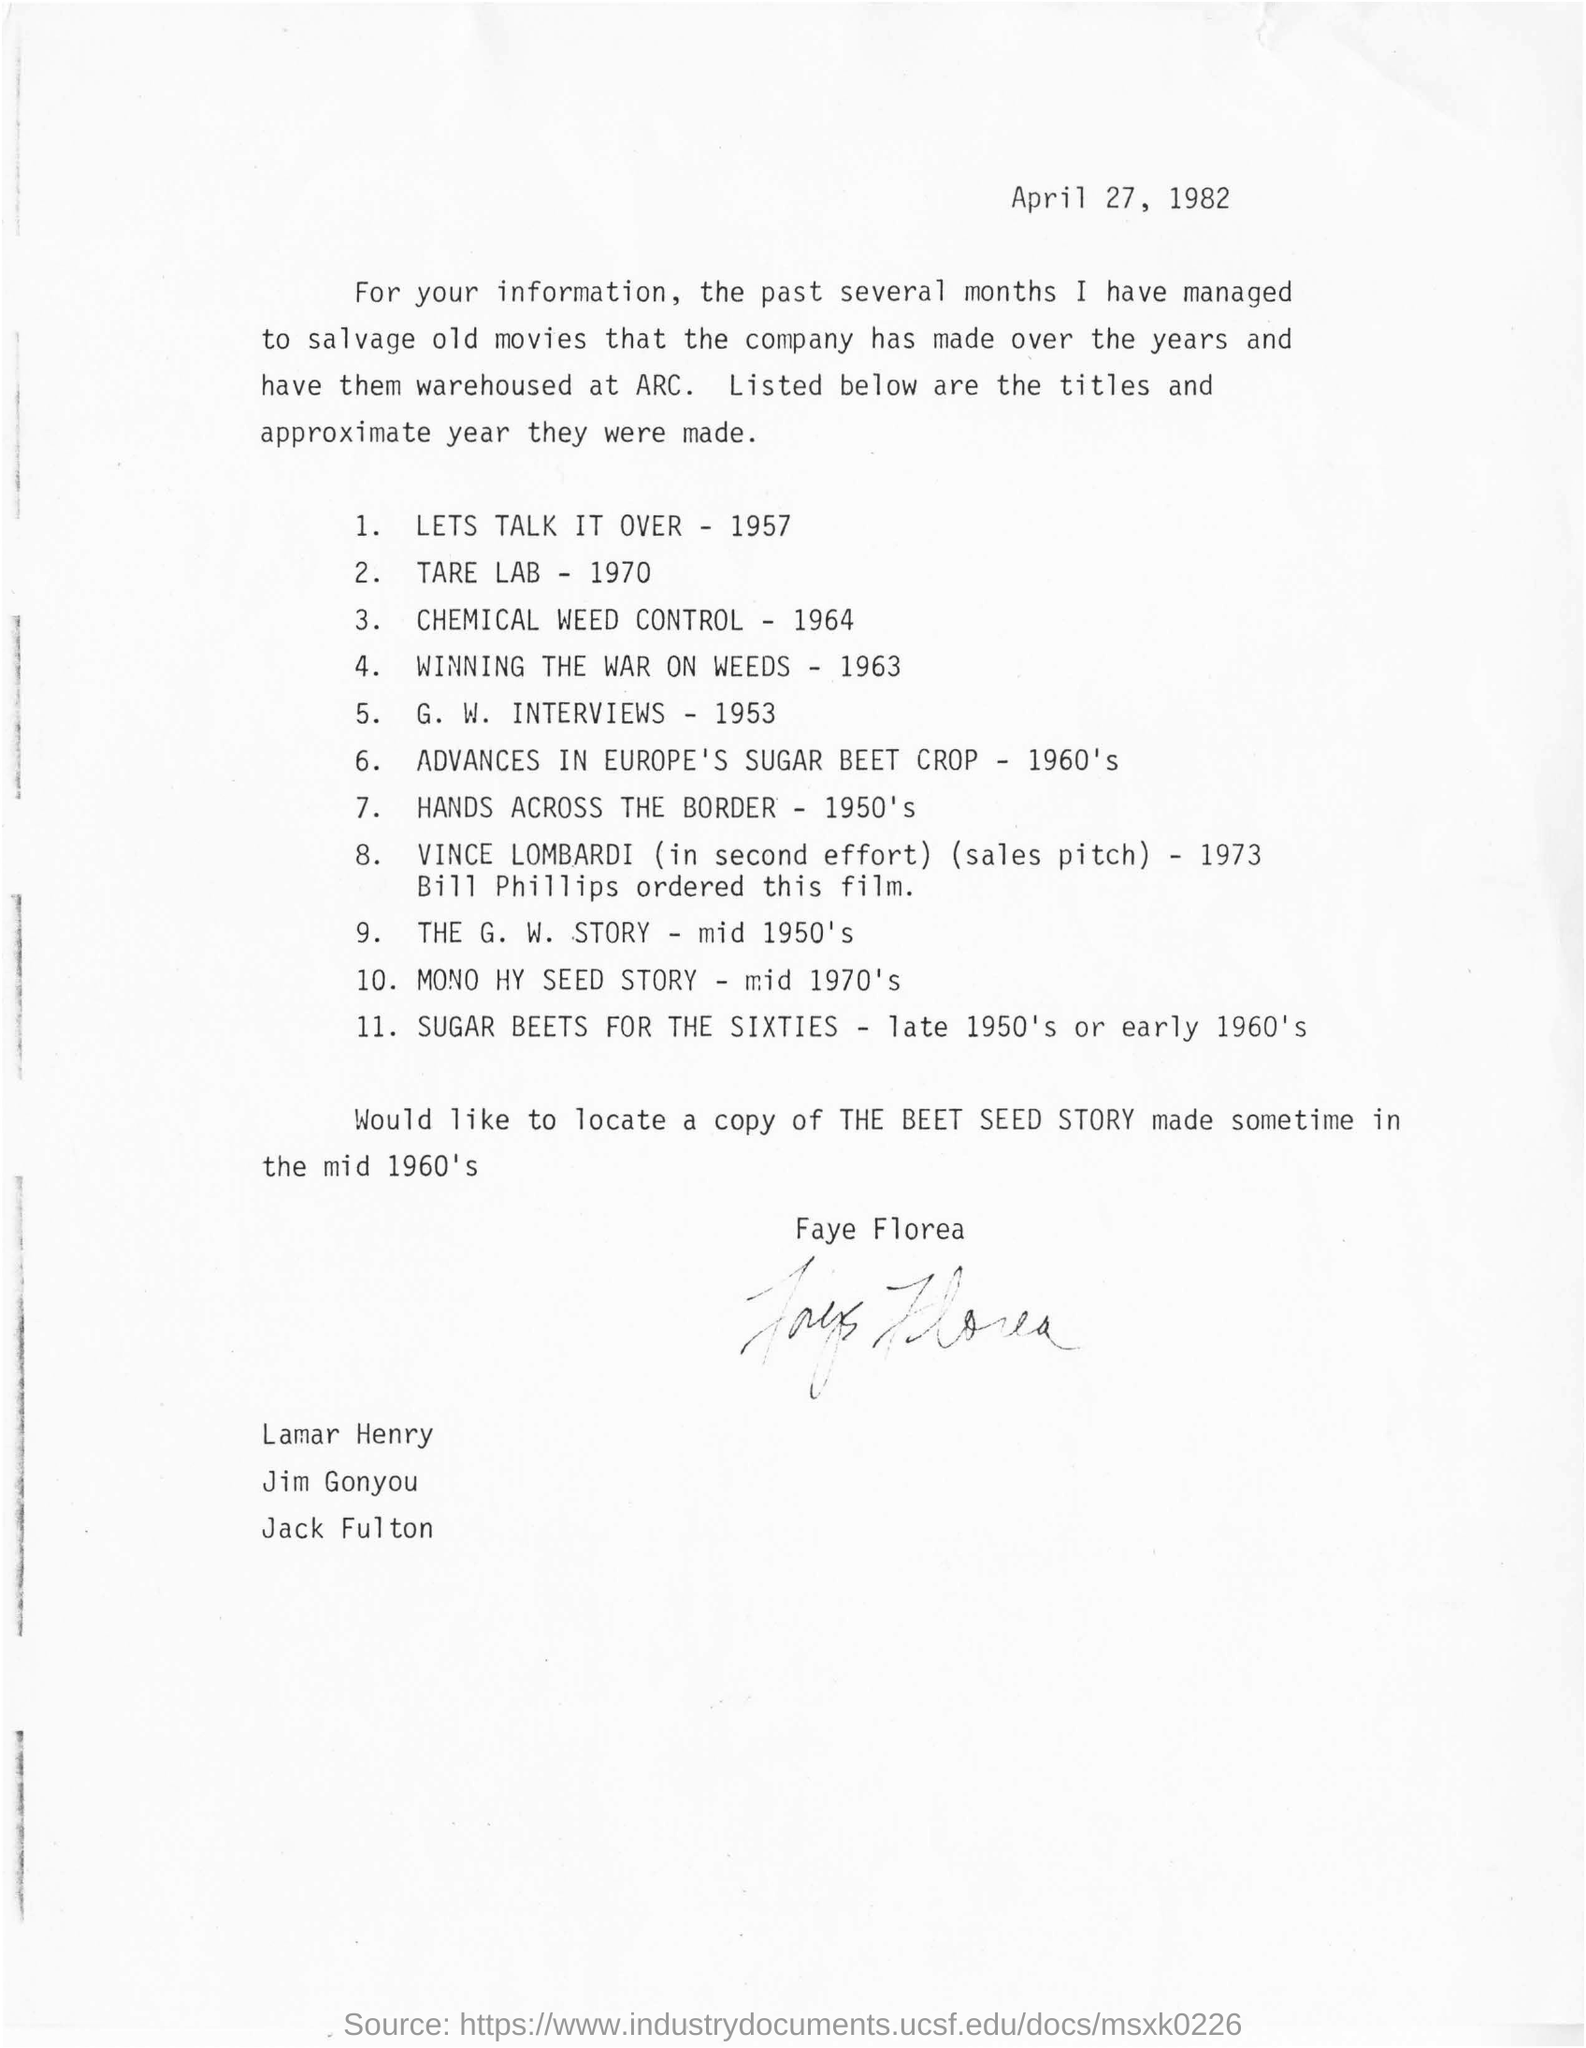What is the date mentioned in this letter
Your answer should be very brief. APRIL 27, 1982. Whose signature at the bottom of the letter?
Provide a succinct answer. FAYE FLOREA. Who ordered the vince lombardi film in 1973?
Offer a terse response. BILL PHILLIPS. Which film is made in late 1950's or early 1960's?
Provide a short and direct response. SUGAR BEETS FOR THE SIXTIES. In which year title of g.w. interviews movie were made?
Provide a succinct answer. 1953. 